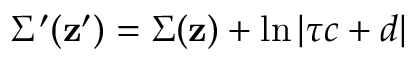Convert formula to latex. <formula><loc_0><loc_0><loc_500><loc_500>\Sigma ^ { \prime } ( { z ^ { \prime } } ) = \Sigma ( { z } ) + \ln \left | \tau c + d \right |</formula> 